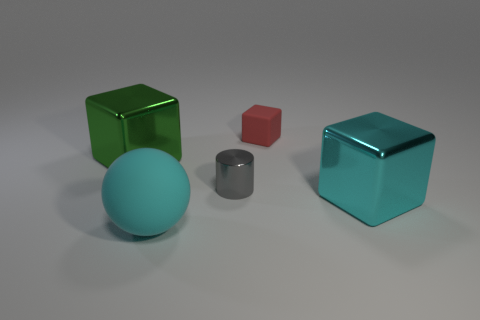How would you describe the lighting and shadows in the scene? The lighting in the scene is soft and diffuse, creating gentle shadows that anchor each object to the floor. There's a sense of ambient illumination coming from multiple directions, giving the objects a calm, realistic appearance. 